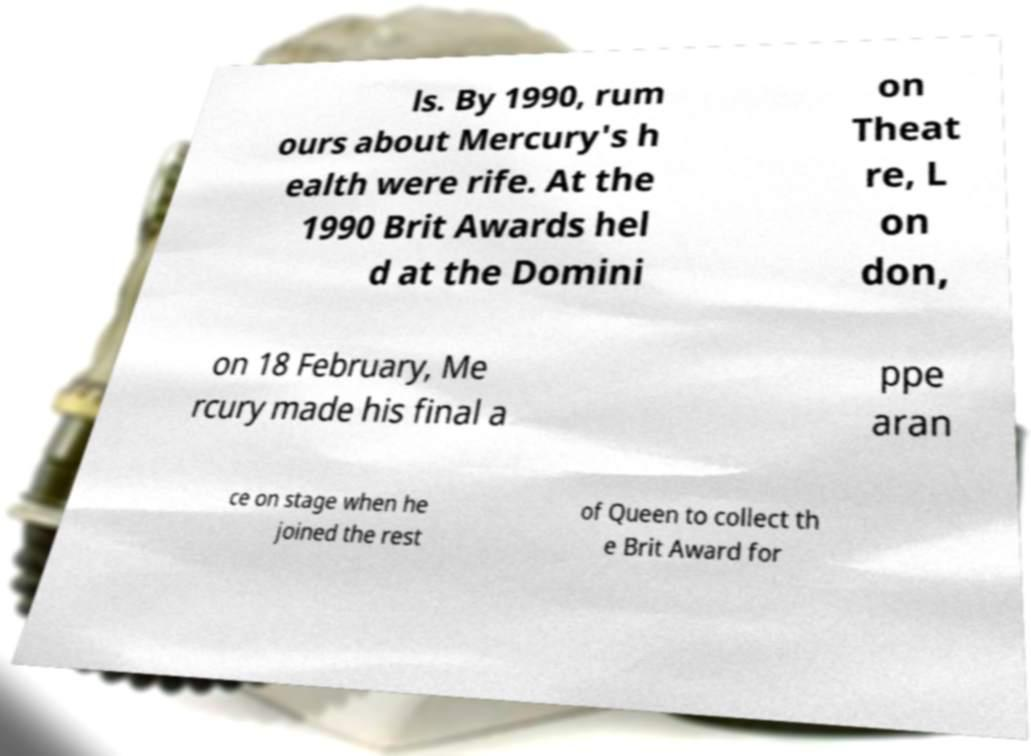What messages or text are displayed in this image? I need them in a readable, typed format. ls. By 1990, rum ours about Mercury's h ealth were rife. At the 1990 Brit Awards hel d at the Domini on Theat re, L on don, on 18 February, Me rcury made his final a ppe aran ce on stage when he joined the rest of Queen to collect th e Brit Award for 